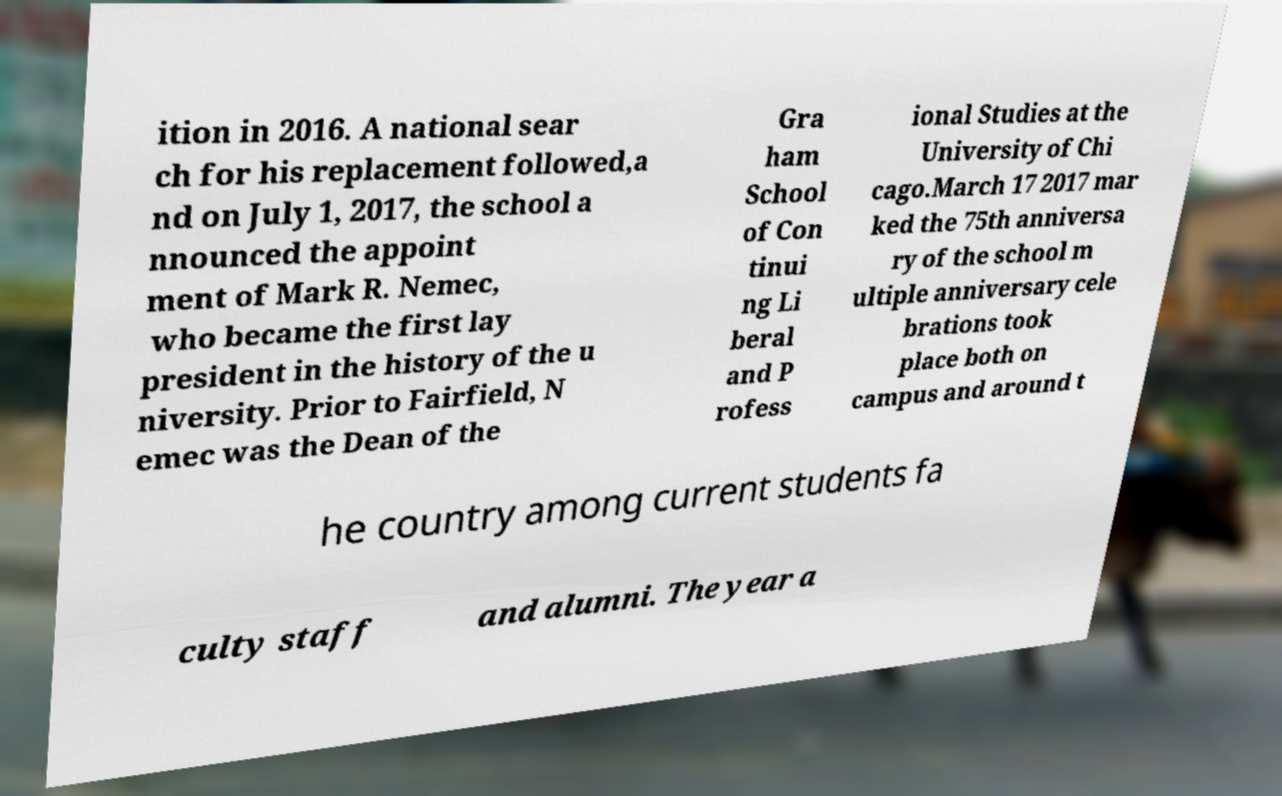Please read and relay the text visible in this image. What does it say? ition in 2016. A national sear ch for his replacement followed,a nd on July 1, 2017, the school a nnounced the appoint ment of Mark R. Nemec, who became the first lay president in the history of the u niversity. Prior to Fairfield, N emec was the Dean of the Gra ham School of Con tinui ng Li beral and P rofess ional Studies at the University of Chi cago.March 17 2017 mar ked the 75th anniversa ry of the school m ultiple anniversary cele brations took place both on campus and around t he country among current students fa culty staff and alumni. The year a 